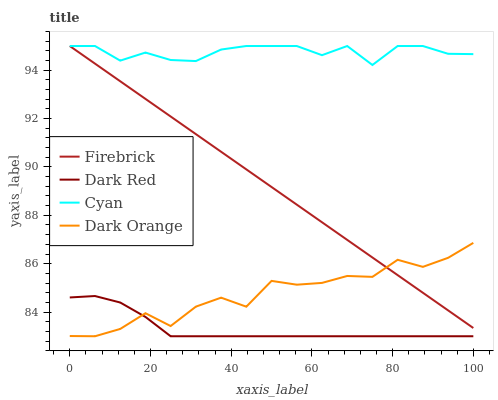Does Dark Red have the minimum area under the curve?
Answer yes or no. Yes. Does Cyan have the maximum area under the curve?
Answer yes or no. Yes. Does Firebrick have the minimum area under the curve?
Answer yes or no. No. Does Firebrick have the maximum area under the curve?
Answer yes or no. No. Is Firebrick the smoothest?
Answer yes or no. Yes. Is Dark Orange the roughest?
Answer yes or no. Yes. Is Dark Red the smoothest?
Answer yes or no. No. Is Dark Red the roughest?
Answer yes or no. No. Does Dark Orange have the lowest value?
Answer yes or no. Yes. Does Firebrick have the lowest value?
Answer yes or no. No. Does Cyan have the highest value?
Answer yes or no. Yes. Does Dark Red have the highest value?
Answer yes or no. No. Is Dark Red less than Firebrick?
Answer yes or no. Yes. Is Cyan greater than Dark Orange?
Answer yes or no. Yes. Does Dark Red intersect Dark Orange?
Answer yes or no. Yes. Is Dark Red less than Dark Orange?
Answer yes or no. No. Is Dark Red greater than Dark Orange?
Answer yes or no. No. Does Dark Red intersect Firebrick?
Answer yes or no. No. 